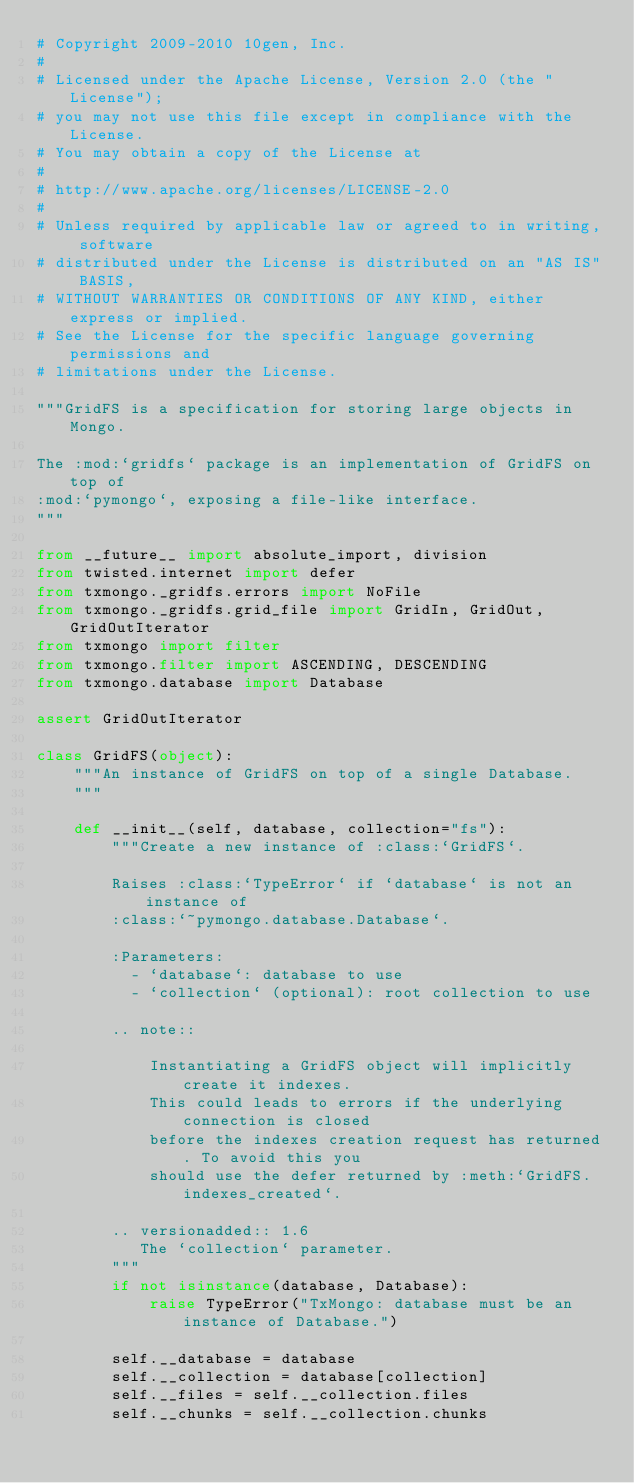<code> <loc_0><loc_0><loc_500><loc_500><_Python_># Copyright 2009-2010 10gen, Inc.
#
# Licensed under the Apache License, Version 2.0 (the "License");
# you may not use this file except in compliance with the License.
# You may obtain a copy of the License at
#
# http://www.apache.org/licenses/LICENSE-2.0
#
# Unless required by applicable law or agreed to in writing, software
# distributed under the License is distributed on an "AS IS" BASIS,
# WITHOUT WARRANTIES OR CONDITIONS OF ANY KIND, either express or implied.
# See the License for the specific language governing permissions and
# limitations under the License.

"""GridFS is a specification for storing large objects in Mongo.

The :mod:`gridfs` package is an implementation of GridFS on top of
:mod:`pymongo`, exposing a file-like interface.
"""

from __future__ import absolute_import, division
from twisted.internet import defer
from txmongo._gridfs.errors import NoFile
from txmongo._gridfs.grid_file import GridIn, GridOut, GridOutIterator
from txmongo import filter
from txmongo.filter import ASCENDING, DESCENDING
from txmongo.database import Database

assert GridOutIterator

class GridFS(object):
    """An instance of GridFS on top of a single Database.
    """

    def __init__(self, database, collection="fs"):
        """Create a new instance of :class:`GridFS`.

        Raises :class:`TypeError` if `database` is not an instance of
        :class:`~pymongo.database.Database`.

        :Parameters:
          - `database`: database to use
          - `collection` (optional): root collection to use

        .. note::

            Instantiating a GridFS object will implicitly create it indexes.
            This could leads to errors if the underlying connection is closed
            before the indexes creation request has returned. To avoid this you
            should use the defer returned by :meth:`GridFS.indexes_created`.

        .. versionadded:: 1.6
           The `collection` parameter.
        """
        if not isinstance(database, Database):
            raise TypeError("TxMongo: database must be an instance of Database.")

        self.__database = database
        self.__collection = database[collection]
        self.__files = self.__collection.files
        self.__chunks = self.__collection.chunks</code> 